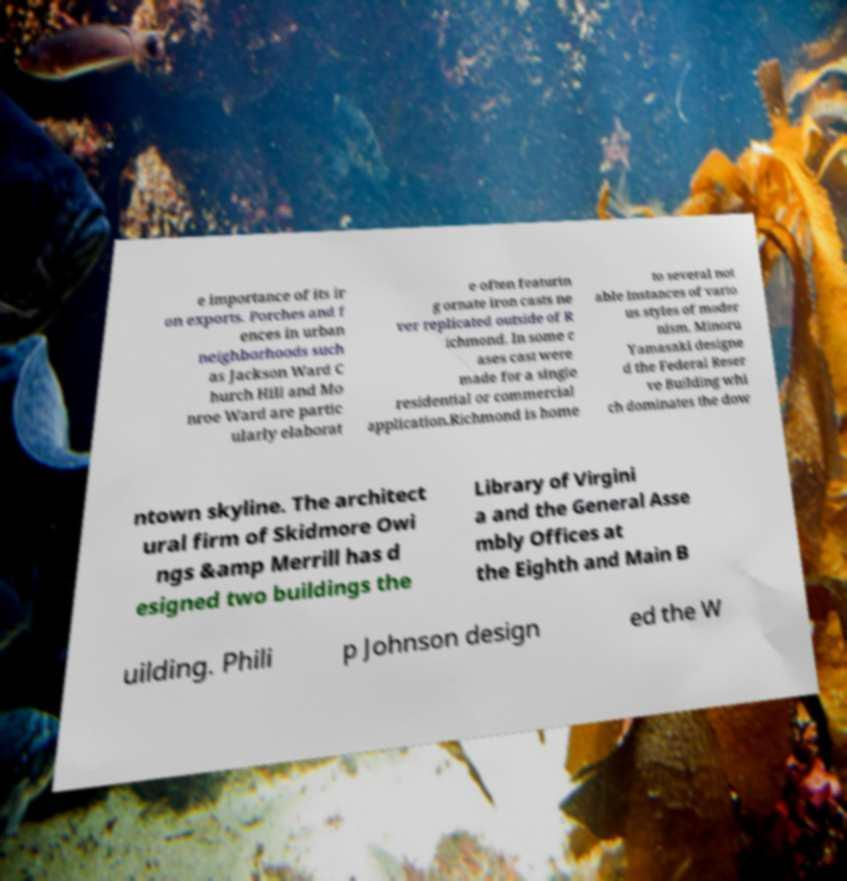There's text embedded in this image that I need extracted. Can you transcribe it verbatim? e importance of its ir on exports. Porches and f ences in urban neighborhoods such as Jackson Ward C hurch Hill and Mo nroe Ward are partic ularly elaborat e often featurin g ornate iron casts ne ver replicated outside of R ichmond. In some c ases cast were made for a single residential or commercial application.Richmond is home to several not able instances of vario us styles of moder nism. Minoru Yamasaki designe d the Federal Reser ve Building whi ch dominates the dow ntown skyline. The architect ural firm of Skidmore Owi ngs &amp Merrill has d esigned two buildings the Library of Virgini a and the General Asse mbly Offices at the Eighth and Main B uilding. Phili p Johnson design ed the W 